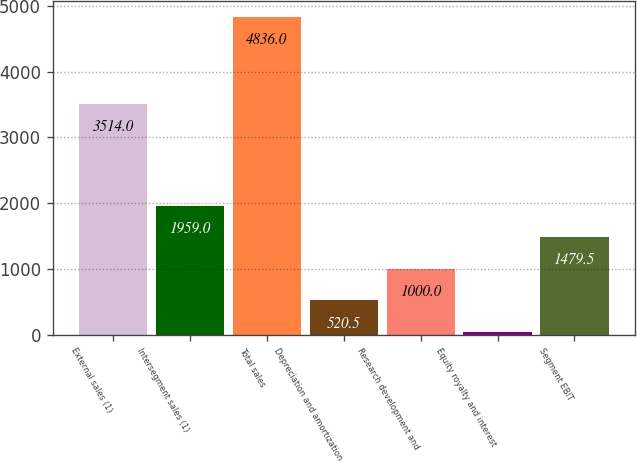Convert chart to OTSL. <chart><loc_0><loc_0><loc_500><loc_500><bar_chart><fcel>External sales (1)<fcel>Intersegment sales (1)<fcel>Total sales<fcel>Depreciation and amortization<fcel>Research development and<fcel>Equity royalty and interest<fcel>Segment EBIT<nl><fcel>3514<fcel>1959<fcel>4836<fcel>520.5<fcel>1000<fcel>41<fcel>1479.5<nl></chart> 